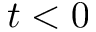Convert formula to latex. <formula><loc_0><loc_0><loc_500><loc_500>t < 0</formula> 